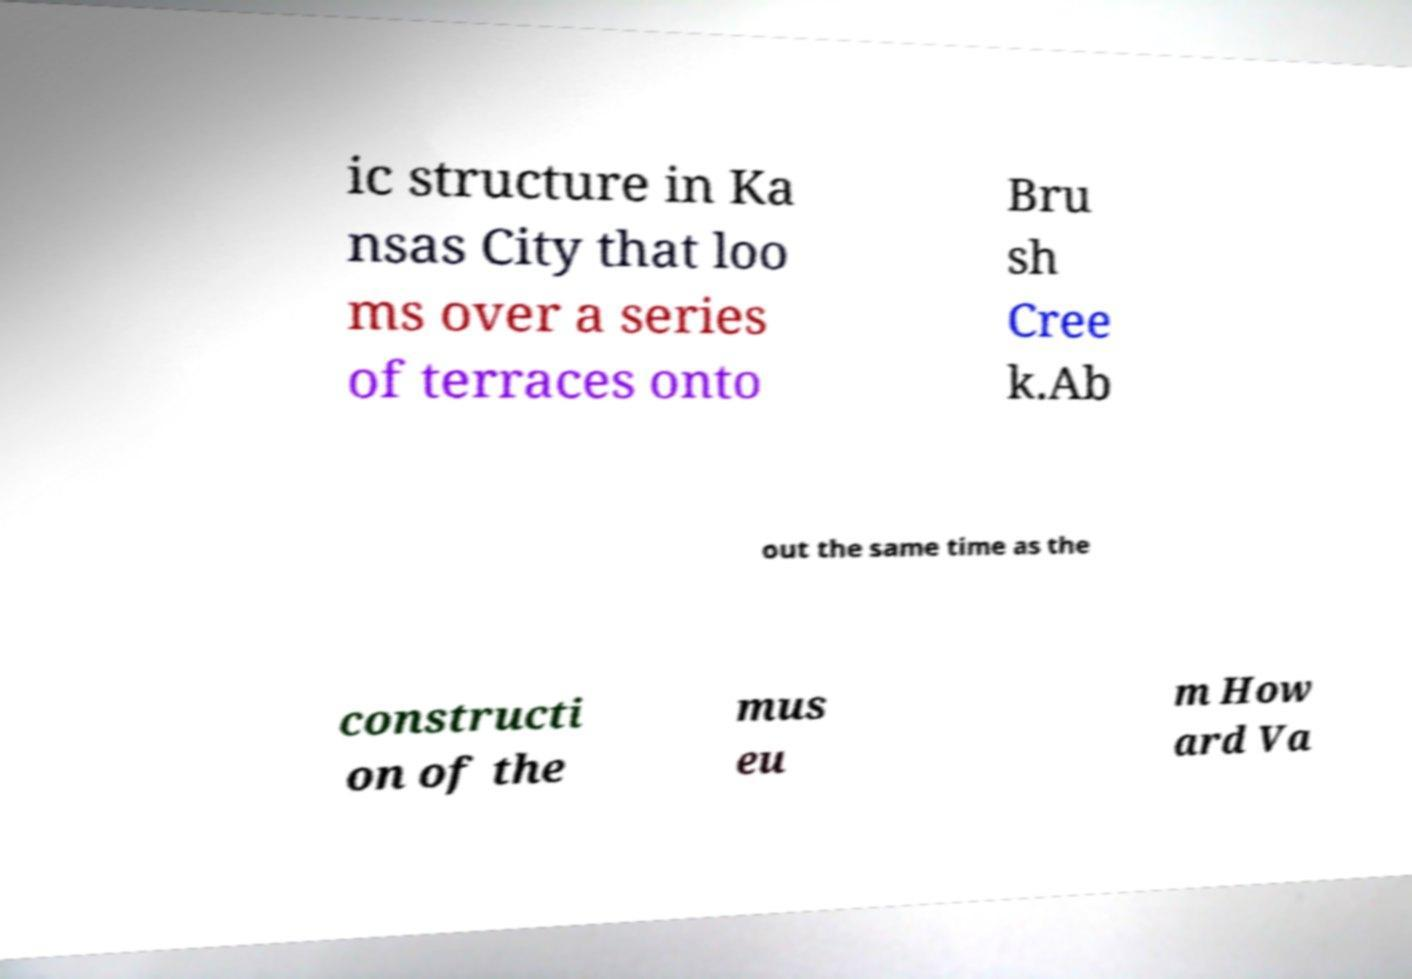There's text embedded in this image that I need extracted. Can you transcribe it verbatim? ic structure in Ka nsas City that loo ms over a series of terraces onto Bru sh Cree k.Ab out the same time as the constructi on of the mus eu m How ard Va 